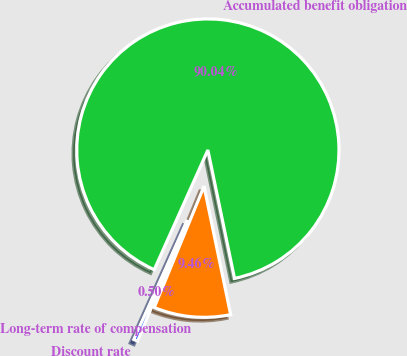Convert chart to OTSL. <chart><loc_0><loc_0><loc_500><loc_500><pie_chart><fcel>Discount rate<fcel>Long-term rate of compensation<fcel>Accumulated benefit obligation<nl><fcel>0.5%<fcel>9.46%<fcel>90.04%<nl></chart> 